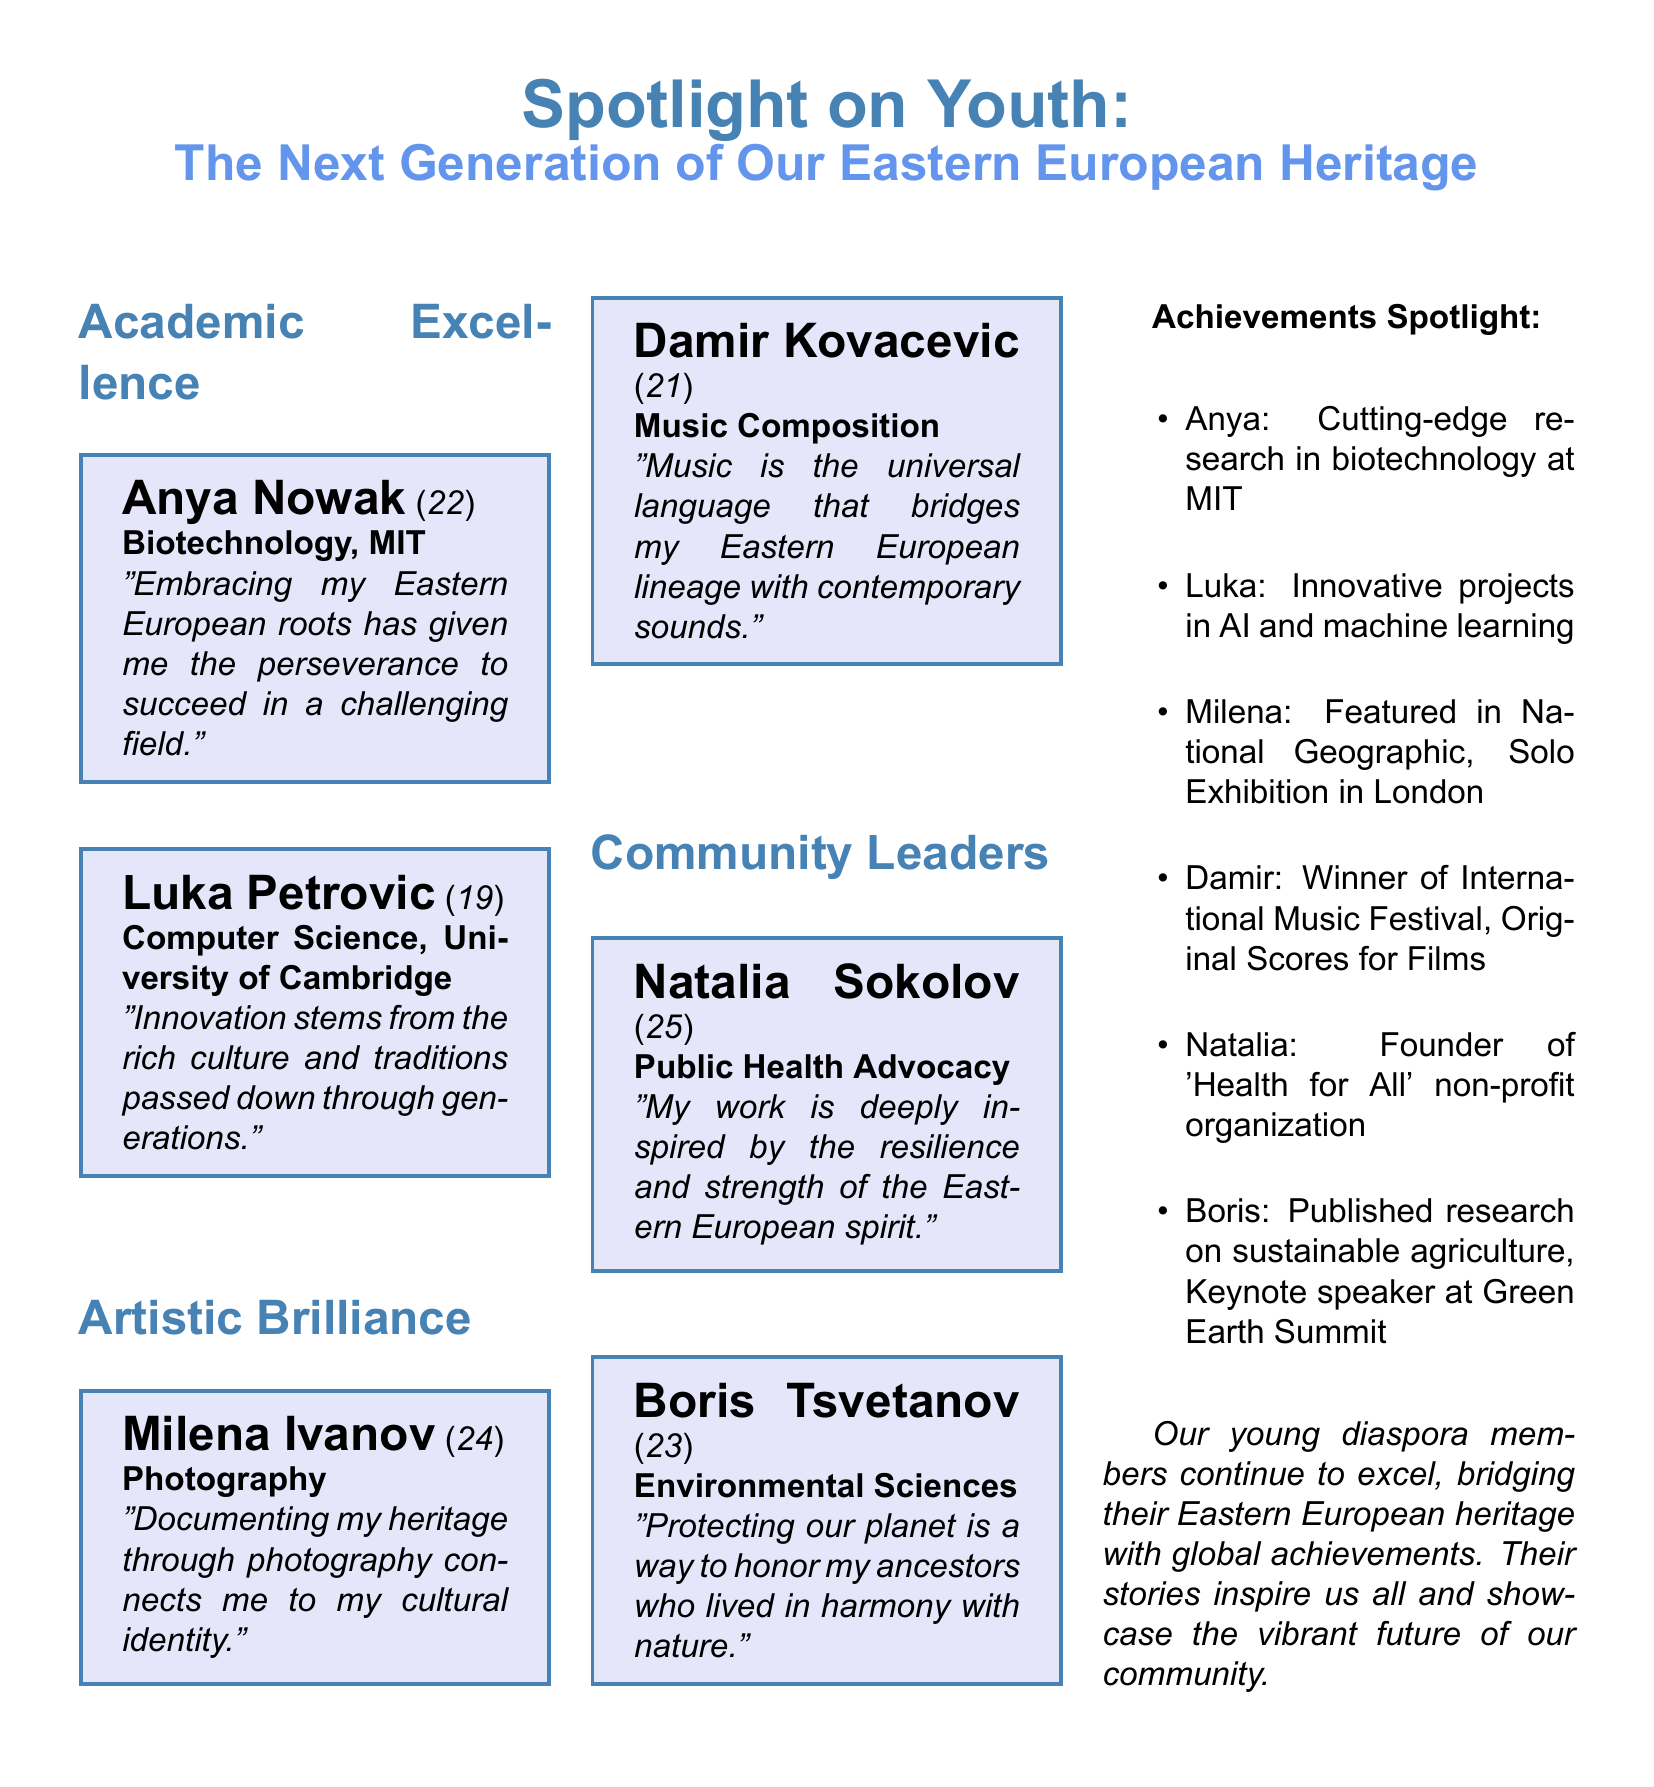What is Anya Nowak's major? Anya Nowak is pursuing a degree in Biotechnology at MIT, which is explicitly stated under her profile.
Answer: Biotechnology How old is Damir Kovacevic? Damir Kovacevic is listed as being 21 years old in the document, according to the information provided in his profile.
Answer: 21 Which university is Luka Petrovic attending? Luka Petrovic's profile indicates that he is studying Computer Science at the University of Cambridge.
Answer: University of Cambridge What is the title of Natalia Sokolov's non-profit organization? The document states that she is the founder of 'Health for All,' providing the title of her organization.
Answer: Health for All Which art form is Milena Ivanov associated with? Milena Ivanov is identified as a photographer in her profile, indicating her area of artistic brilliance.
Answer: Photography What theme do all profiles in this document revolve around? Each profile reflects on personal connections to heritage, meaning the cultural identity shared among diaspora members.
Answer: Heritage What type of event did Damir Kovacevic win? It is mentioned that Damir won an International Music Festival, showcasing his excellence in music composition.
Answer: International Music Festival What is a common element across the profiles in the 'Community Leaders' section? Both profiles in this section highlight advocacies that resonate deeply with cultural roots and heritage significance.
Answer: Cultural roots How is the layout of the document structured? The document is organized into columns that categorize profiles into sections like Academic Excellence, Artistic Brilliance, and Community Leaders.
Answer: Columns 